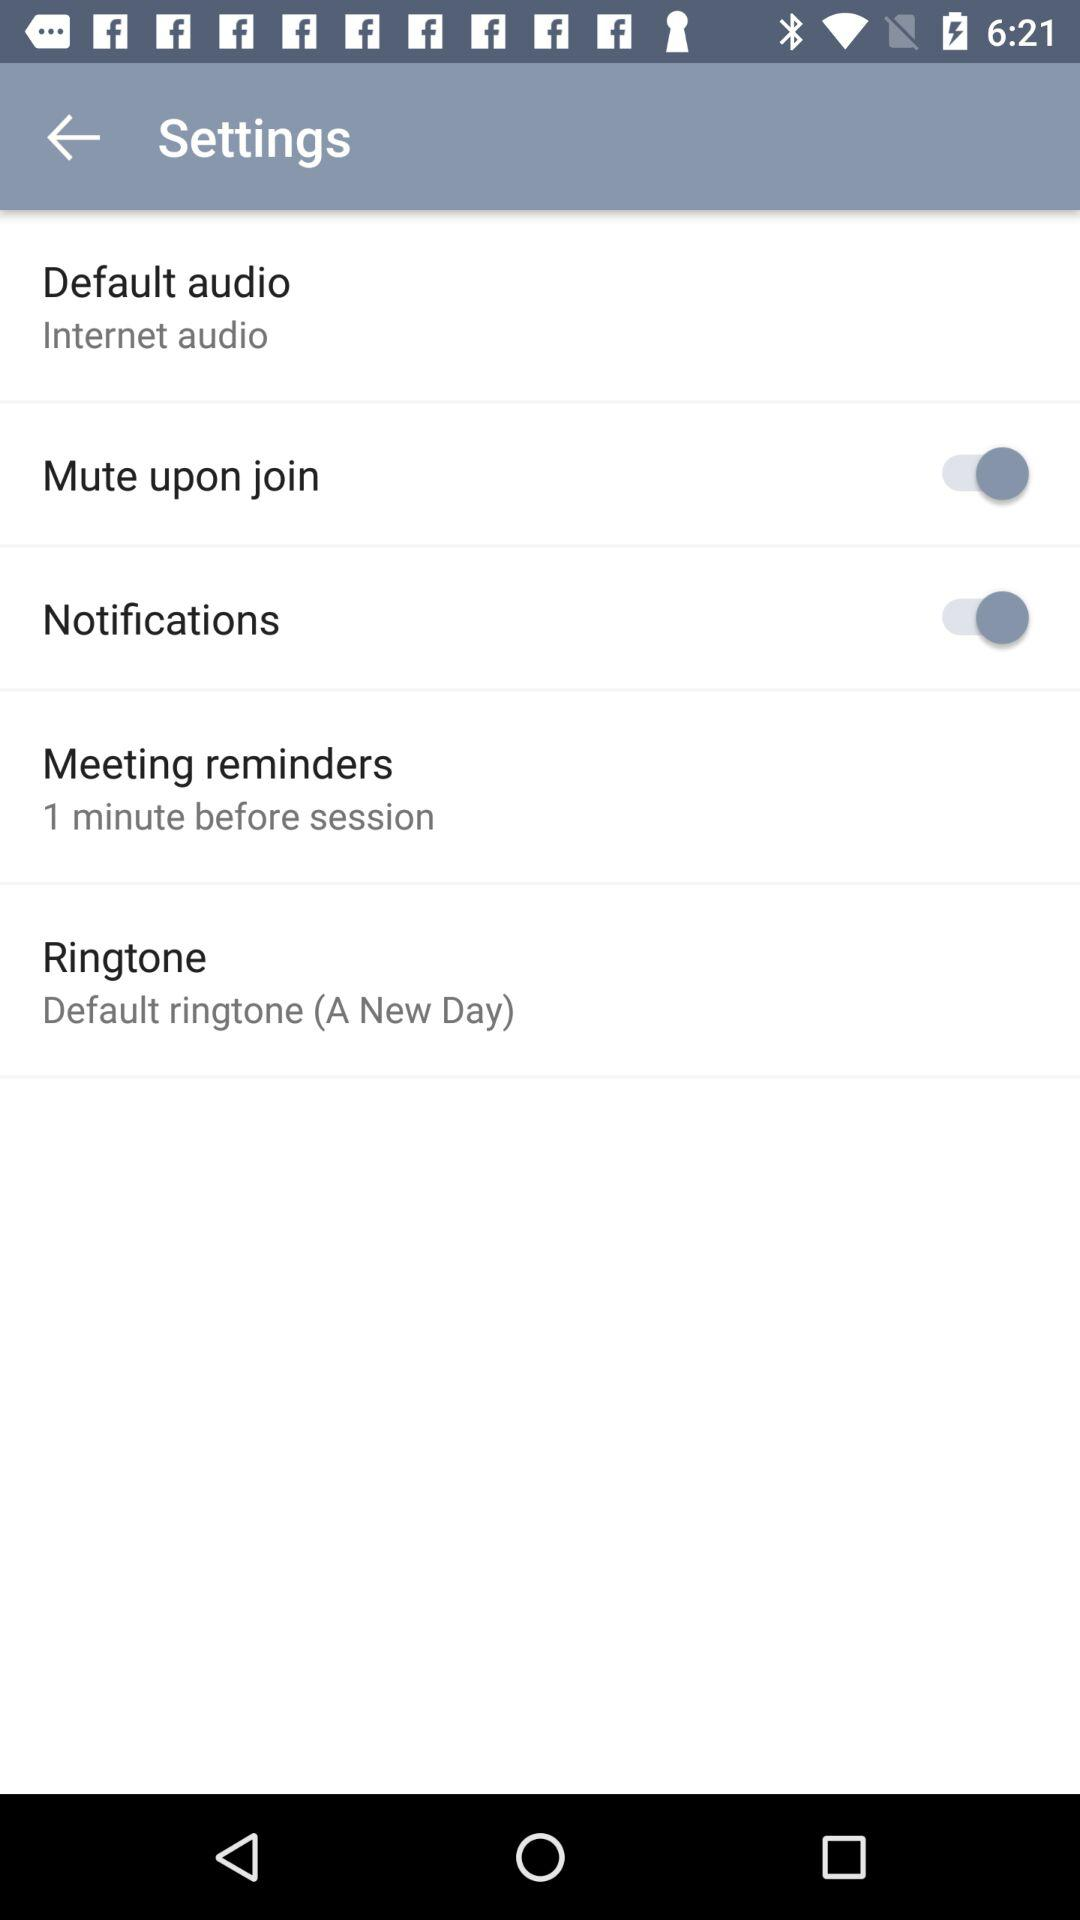What is the current state of the "Mute upon join"? The current state is on. 